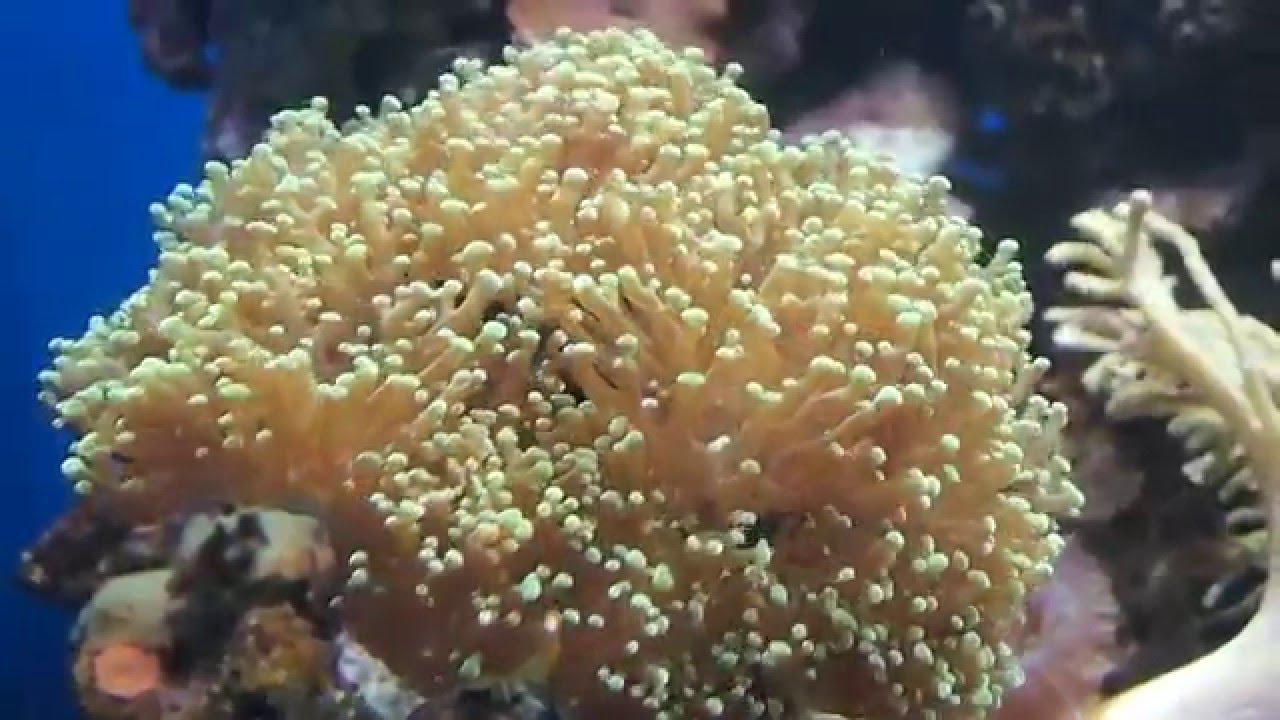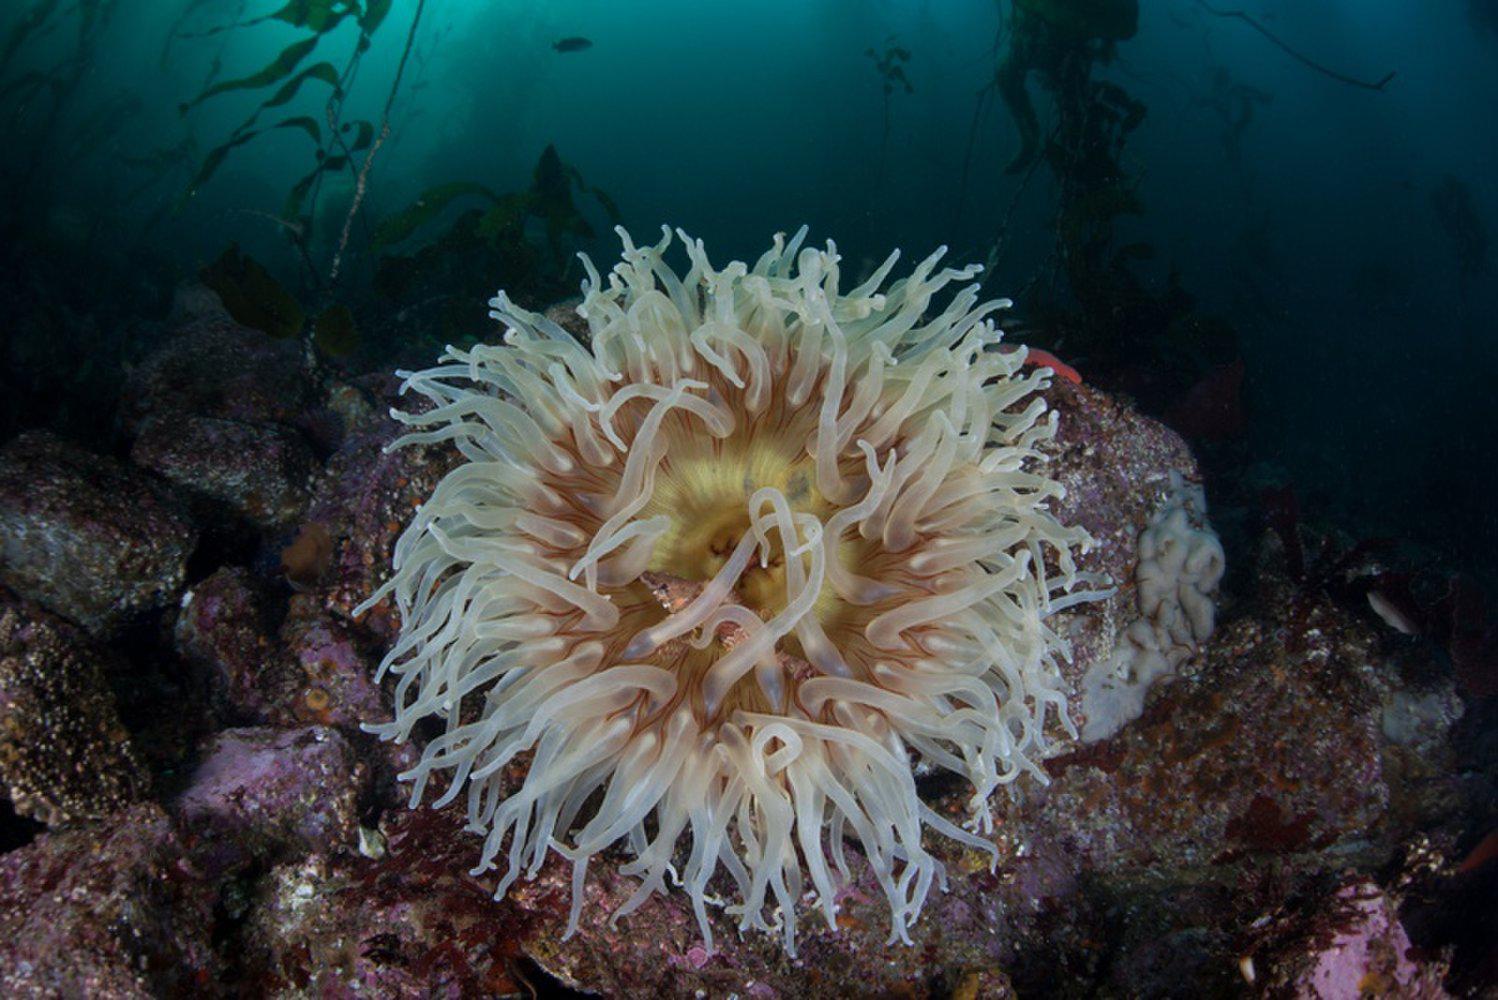The first image is the image on the left, the second image is the image on the right. Considering the images on both sides, is "One image shows a flower-look anemone with tapering tendrils around a flat center, and the other shows one large anemone with densely-packed neutral-colored tendrils." valid? Answer yes or no. Yes. 